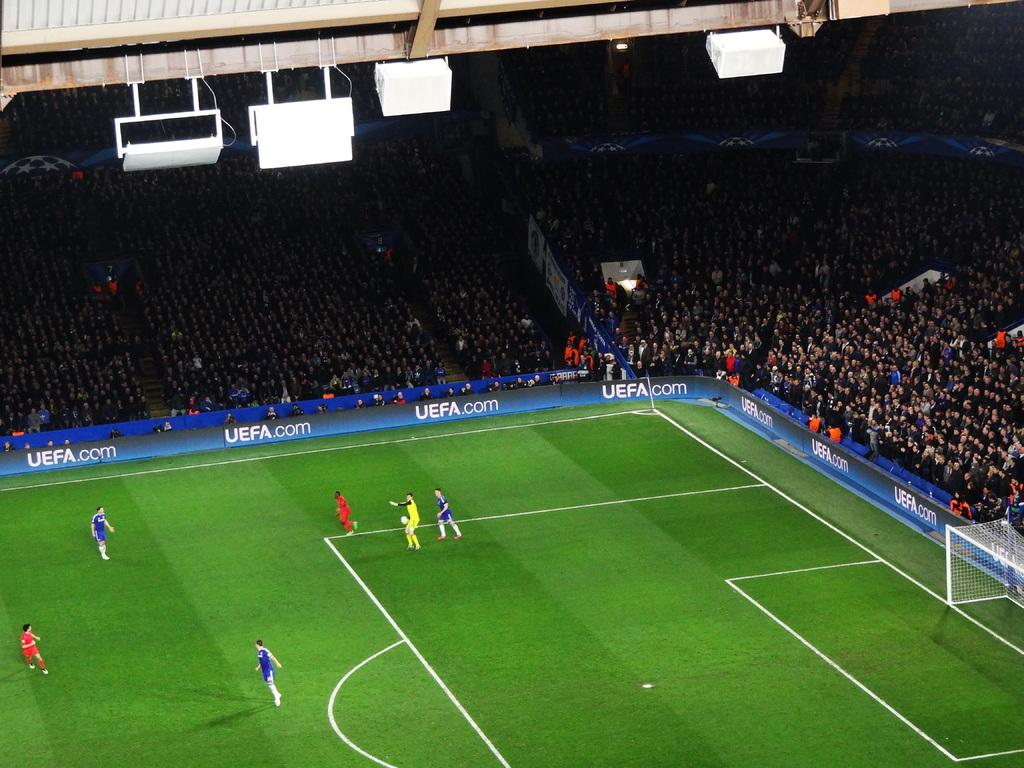<image>
Write a terse but informative summary of the picture. A website address for the UEFA is featured around the perimeter of a green grassy soccer field. 